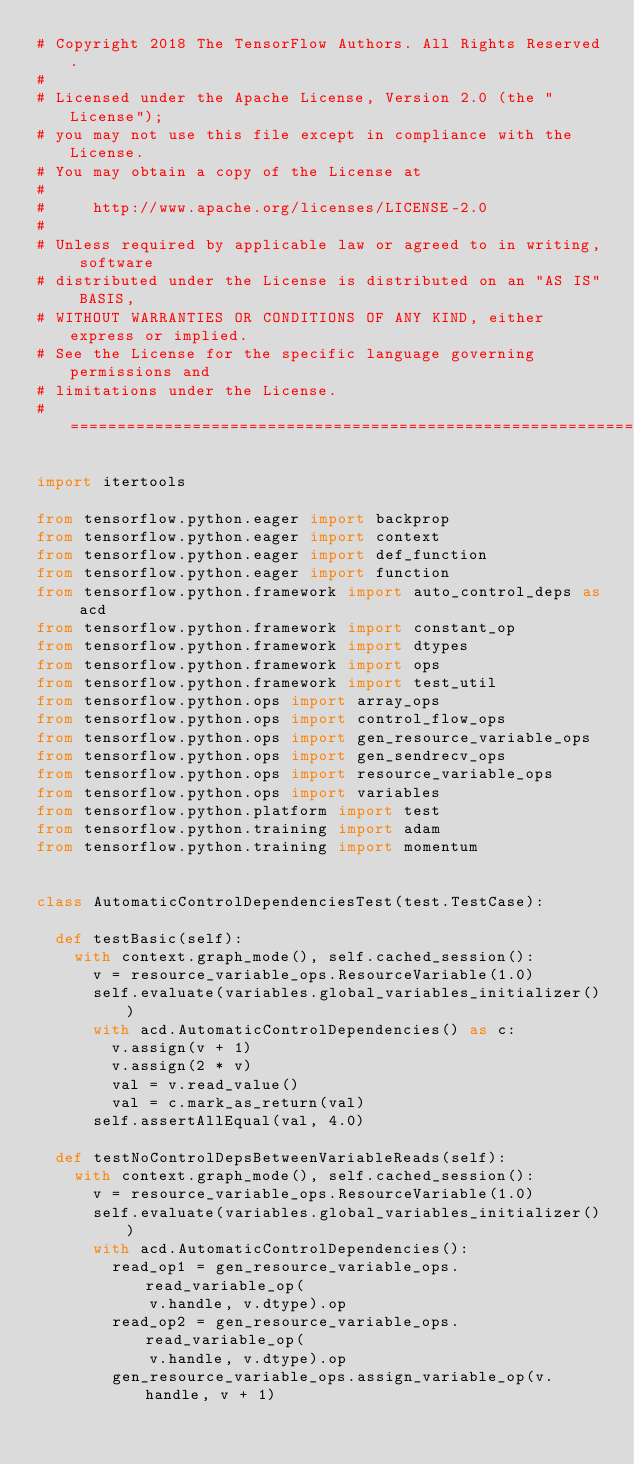Convert code to text. <code><loc_0><loc_0><loc_500><loc_500><_Python_># Copyright 2018 The TensorFlow Authors. All Rights Reserved.
#
# Licensed under the Apache License, Version 2.0 (the "License");
# you may not use this file except in compliance with the License.
# You may obtain a copy of the License at
#
#     http://www.apache.org/licenses/LICENSE-2.0
#
# Unless required by applicable law or agreed to in writing, software
# distributed under the License is distributed on an "AS IS" BASIS,
# WITHOUT WARRANTIES OR CONDITIONS OF ANY KIND, either express or implied.
# See the License for the specific language governing permissions and
# limitations under the License.
# ==============================================================================

import itertools

from tensorflow.python.eager import backprop
from tensorflow.python.eager import context
from tensorflow.python.eager import def_function
from tensorflow.python.eager import function
from tensorflow.python.framework import auto_control_deps as acd
from tensorflow.python.framework import constant_op
from tensorflow.python.framework import dtypes
from tensorflow.python.framework import ops
from tensorflow.python.framework import test_util
from tensorflow.python.ops import array_ops
from tensorflow.python.ops import control_flow_ops
from tensorflow.python.ops import gen_resource_variable_ops
from tensorflow.python.ops import gen_sendrecv_ops
from tensorflow.python.ops import resource_variable_ops
from tensorflow.python.ops import variables
from tensorflow.python.platform import test
from tensorflow.python.training import adam
from tensorflow.python.training import momentum


class AutomaticControlDependenciesTest(test.TestCase):

  def testBasic(self):
    with context.graph_mode(), self.cached_session():
      v = resource_variable_ops.ResourceVariable(1.0)
      self.evaluate(variables.global_variables_initializer())
      with acd.AutomaticControlDependencies() as c:
        v.assign(v + 1)
        v.assign(2 * v)
        val = v.read_value()
        val = c.mark_as_return(val)
      self.assertAllEqual(val, 4.0)

  def testNoControlDepsBetweenVariableReads(self):
    with context.graph_mode(), self.cached_session():
      v = resource_variable_ops.ResourceVariable(1.0)
      self.evaluate(variables.global_variables_initializer())
      with acd.AutomaticControlDependencies():
        read_op1 = gen_resource_variable_ops.read_variable_op(
            v.handle, v.dtype).op
        read_op2 = gen_resource_variable_ops.read_variable_op(
            v.handle, v.dtype).op
        gen_resource_variable_ops.assign_variable_op(v.handle, v + 1)</code> 